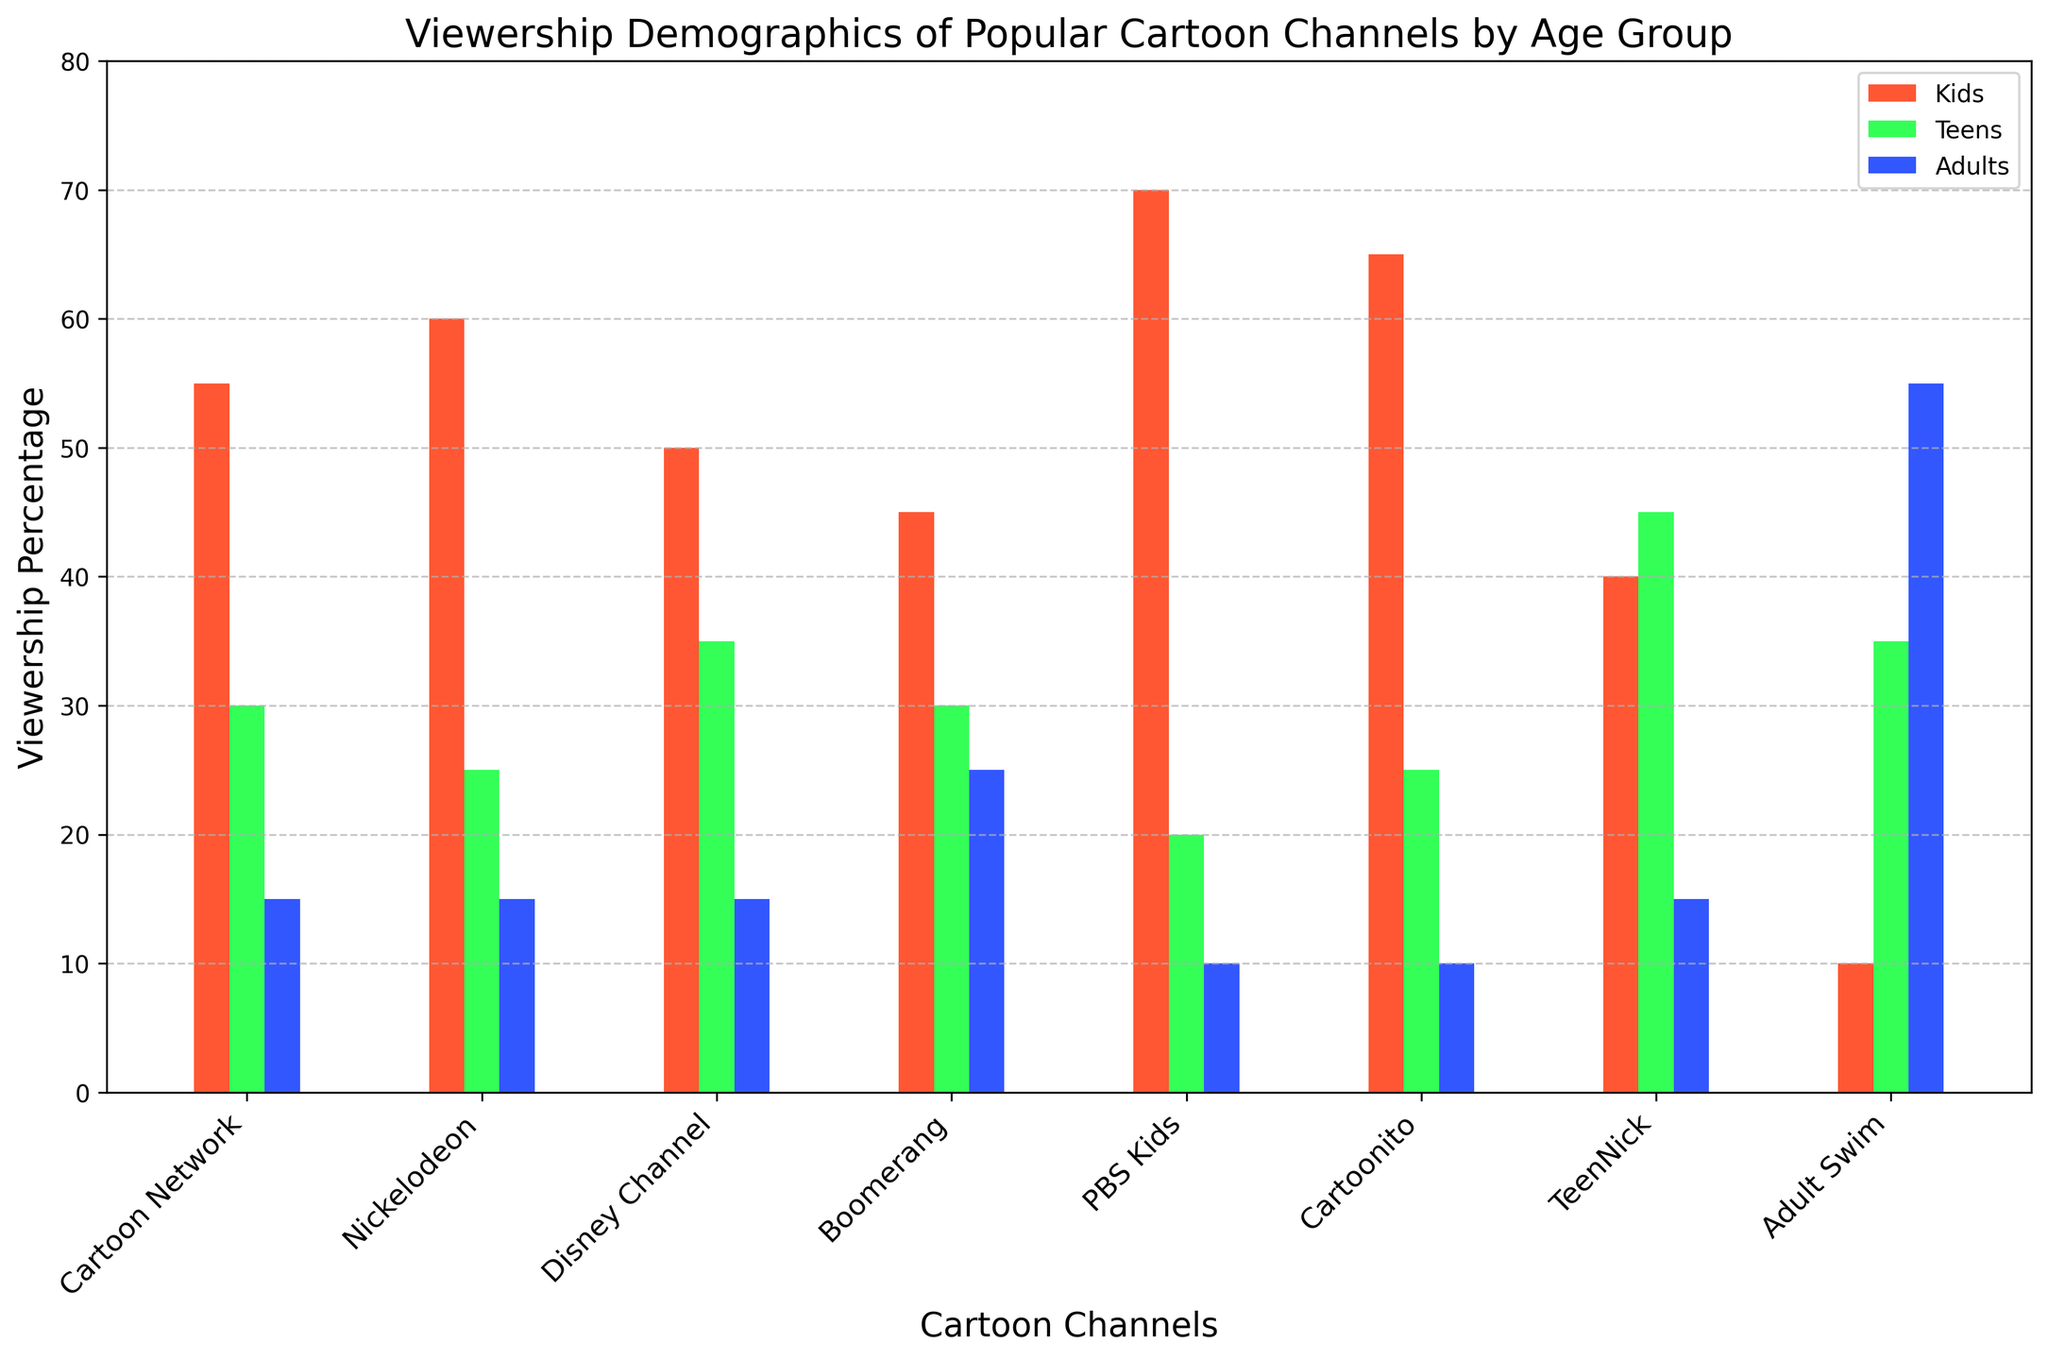Which channel has the highest viewership percentage among kids? By looking at the height of the bars representing kids' viewership percentages, we can see that PBS Kids has the tallest bar among the channels, indicating the highest viewership percentage.
Answer: PBS Kids What is the total viewership percentage for adults across all channels? To find the answer, sum the viewership percentages for adults across all channels: 15 (Cartoon Network) + 15 (Nickelodeon) + 15 (Disney Channel) + 25 (Boomerang) + 10 (PBS Kids) + 10 (Cartoonito) + 15 (TeenNick) + 55 (Adult Swim). The total is 160.
Answer: 160 Which age group has the most consistent viewership percentage across all channels, and what is the range of percentages? The percentages for each age group need to be examined. The range is found by subtracting the smallest percentage from the largest. Kids: 70 - 10, Teens: 45 - 20, Adults: 55 - 10. Teens have the smallest range of 25 (45 - 20).
Answer: Teens, Range: 25 Compare the viewership percentage of Boomerang and Cartoonito among teens. Which one is higher? By comparing the height of the bars for the teen group for Boomerang and Cartoonito, we see that both have equal bars at 30 and 25 respectively. Cartoonito has a lower viewership percentage among teens.
Answer: Boomerang What is the average viewership percentage among kids for Cartoon Network, Nickelodeon, and Disney Channel? First, sum the viewership percentages for kids for these three channels: 55 (Cartoon Network) + 60 (Nickelodeon) + 50 (Disney Channel). Then, divide by the number of channels, which is 3. The calculation is (55 + 60 + 50) / 3 = 55.
Answer: 55 Which channel has the highest viewership percentage among adults? By looking at the bars representing adults' viewership percentages, Adult Swim has the tallest bar among the channels, indicating the highest viewership percentage for adults.
Answer: Adult Swim What is the difference in kids' viewership percentages between Cartoonito and Disney Channel? Subtract the kids' viewership percentage of Disney Channel from Cartoonito: 65 (Cartoonito) - 50 (Disney Channel) = 15.
Answer: 15 What is the combined viewership percentage for teens on TeenNick and Adult Swim? Sum the viewership percentages for teens for these two channels: 45 (TeenNick) + 35 (Adult Swim). The combined viewership percentage is 80.
Answer: 80 Which channel shows a more balanced viewership distribution across all age groups? By visually inspecting the plot, Boomerang shows a more balanced distribution across kids, teens, and adults, with percentages relatively close to each other: 45, 30, 25.
Answer: Boomerang 